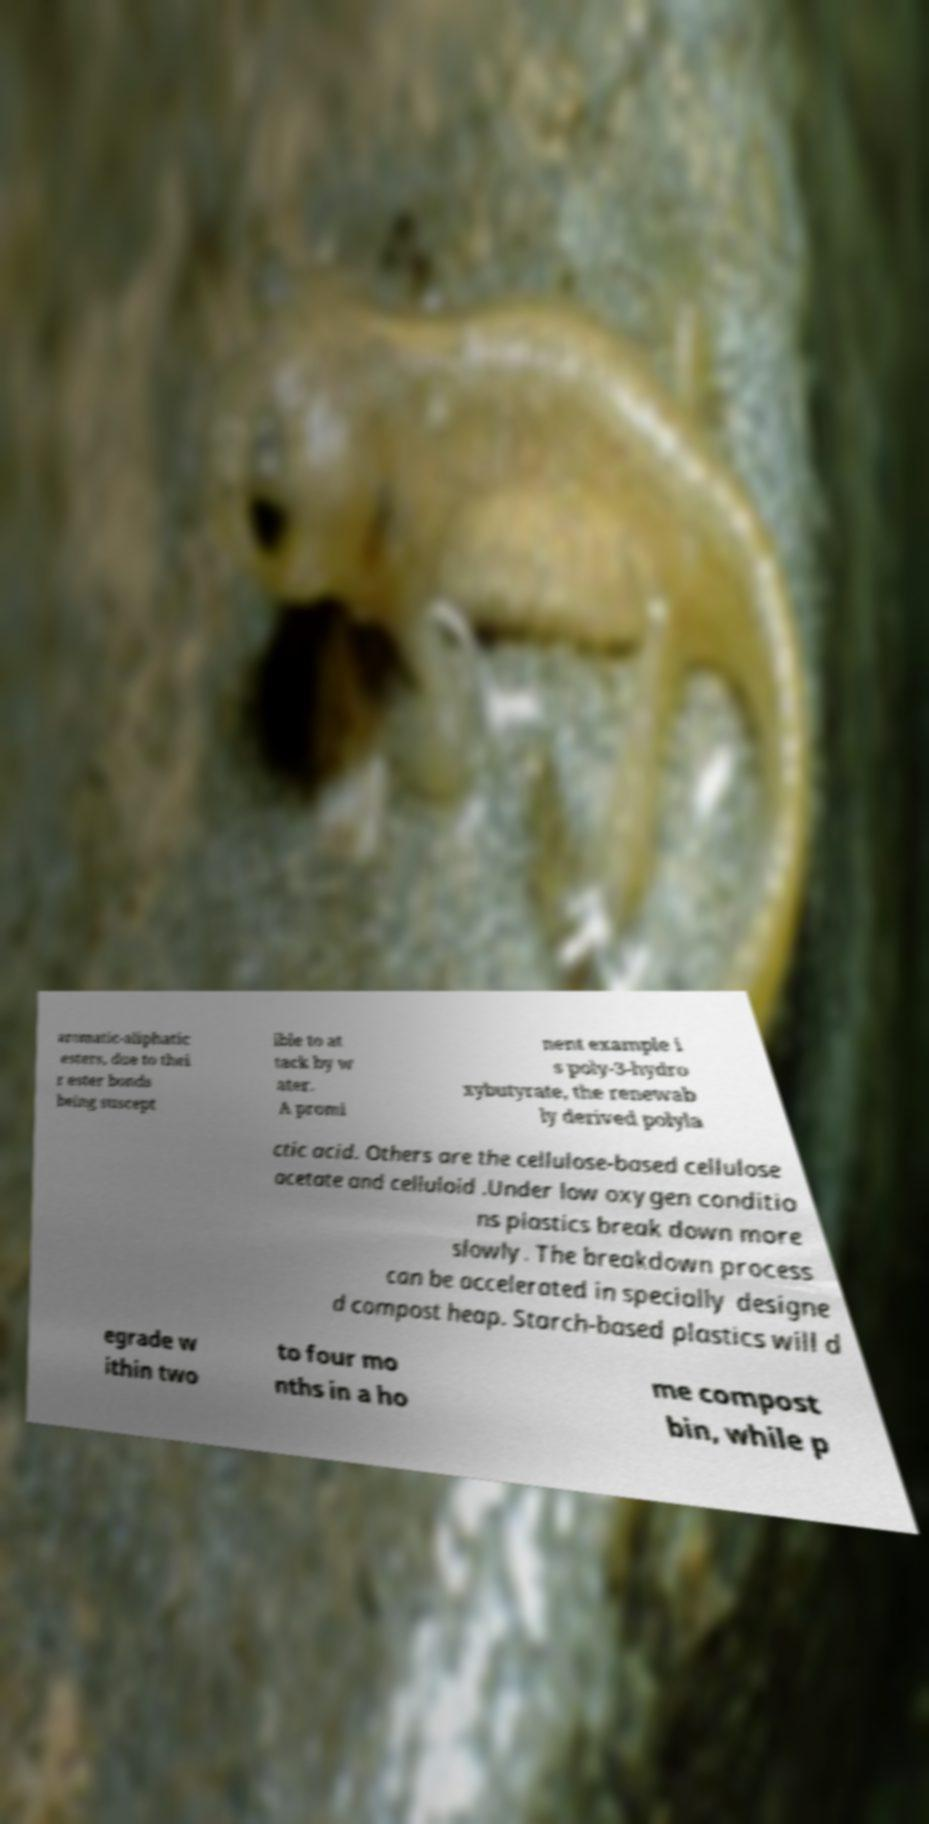I need the written content from this picture converted into text. Can you do that? aromatic-aliphatic esters, due to thei r ester bonds being suscept ible to at tack by w ater. A promi nent example i s poly-3-hydro xybutyrate, the renewab ly derived polyla ctic acid. Others are the cellulose-based cellulose acetate and celluloid .Under low oxygen conditio ns plastics break down more slowly. The breakdown process can be accelerated in specially designe d compost heap. Starch-based plastics will d egrade w ithin two to four mo nths in a ho me compost bin, while p 